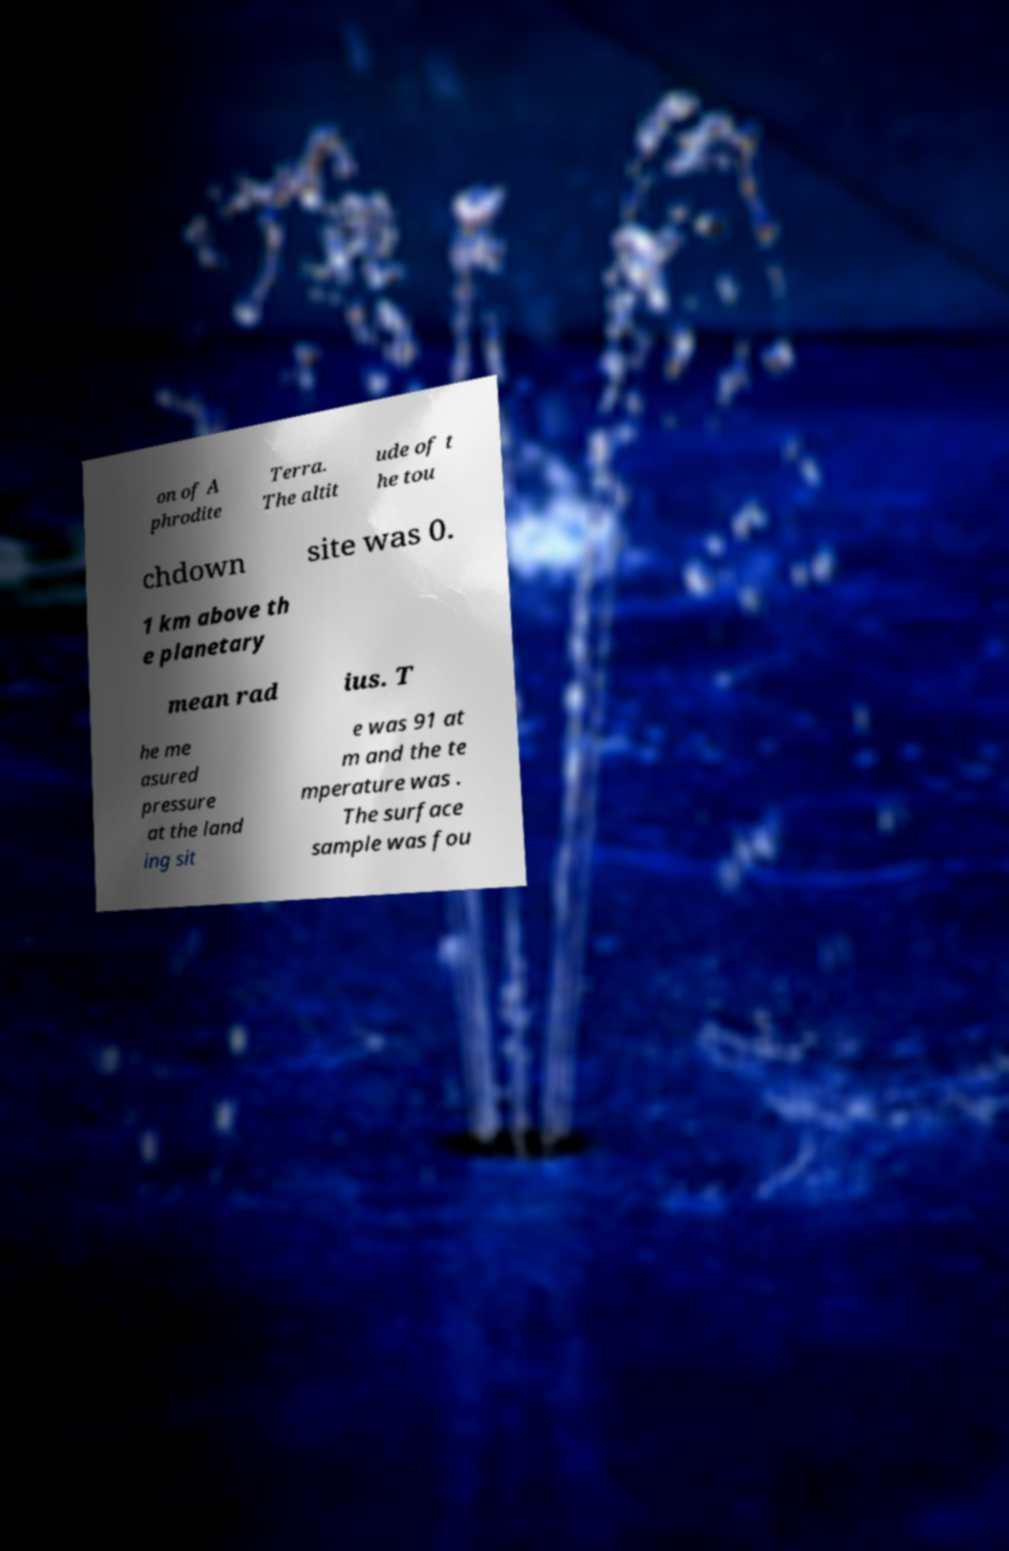I need the written content from this picture converted into text. Can you do that? on of A phrodite Terra. The altit ude of t he tou chdown site was 0. 1 km above th e planetary mean rad ius. T he me asured pressure at the land ing sit e was 91 at m and the te mperature was . The surface sample was fou 